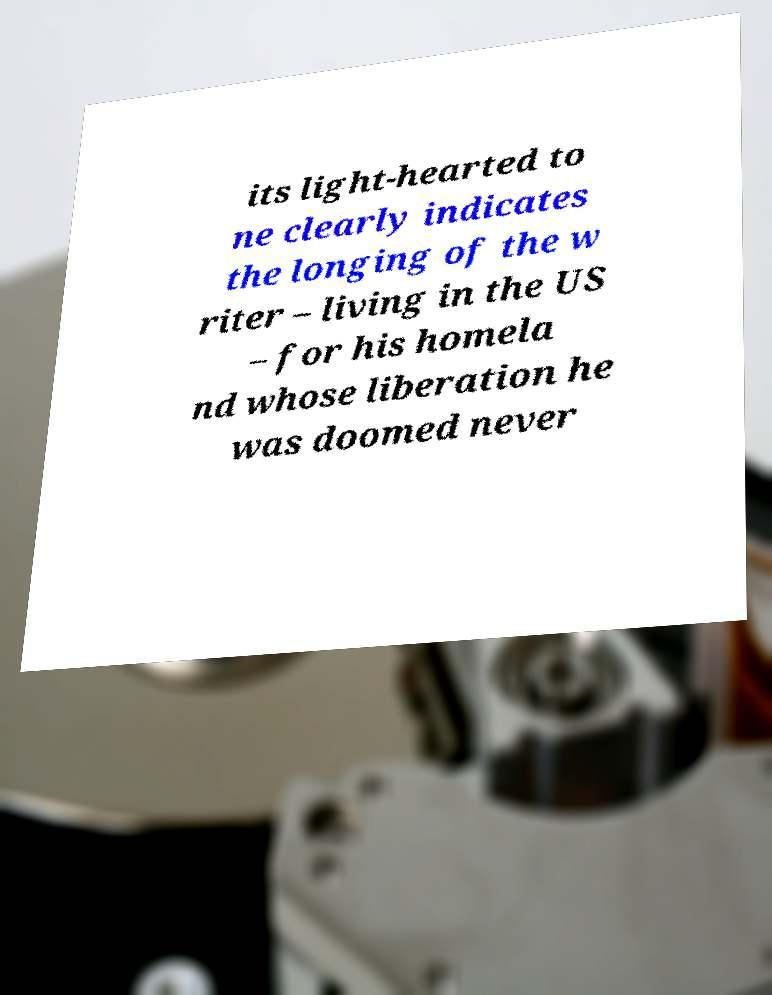Please identify and transcribe the text found in this image. its light-hearted to ne clearly indicates the longing of the w riter – living in the US – for his homela nd whose liberation he was doomed never 